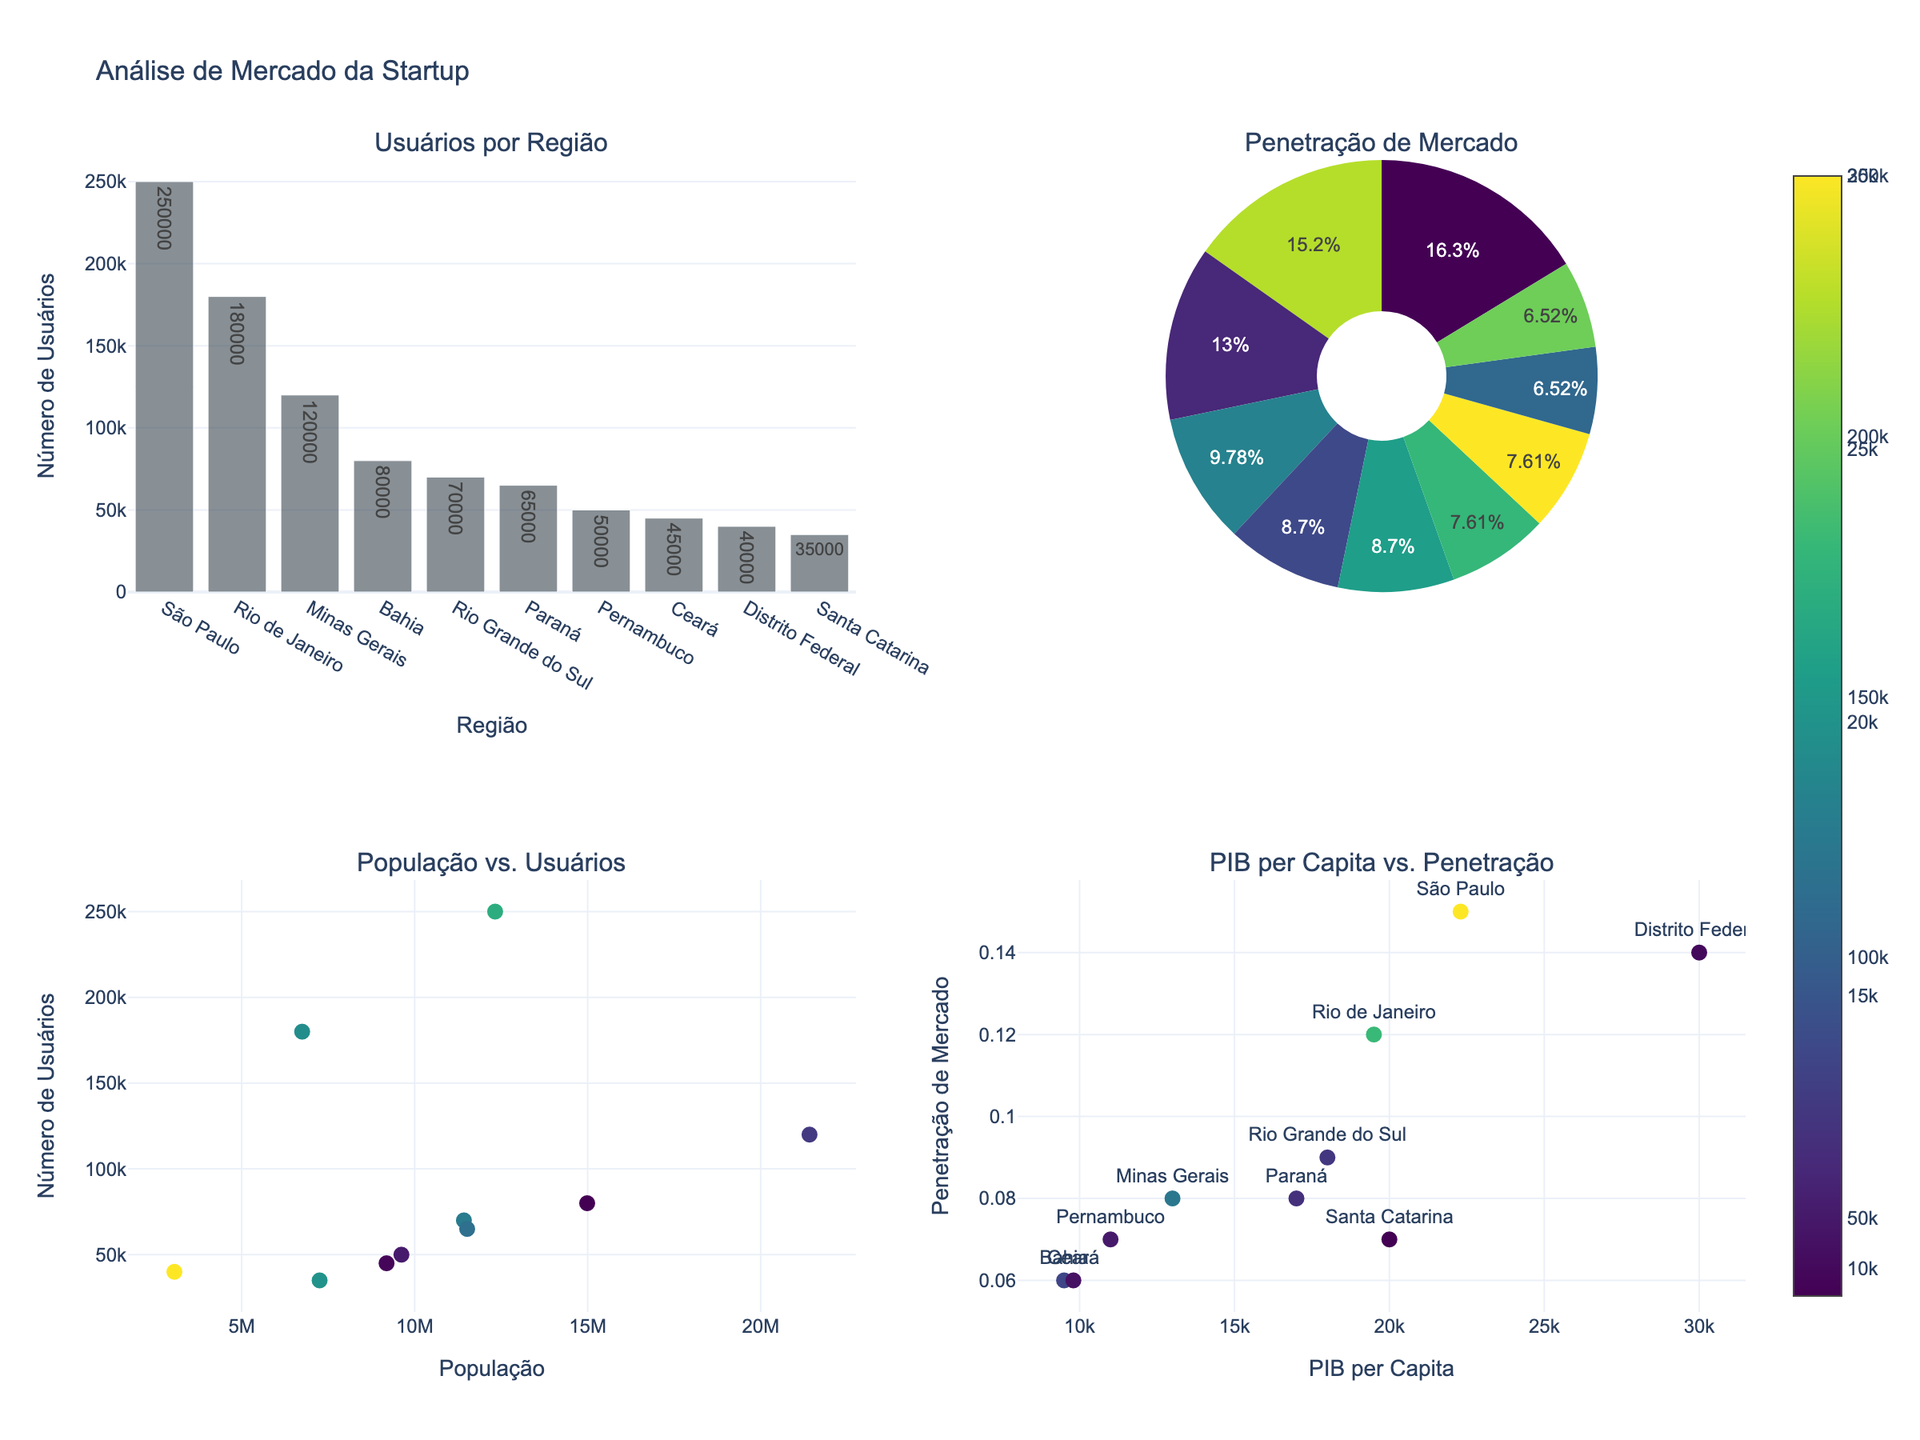What's the region with the highest number of users? The bar chart on the top-left subplot shows the number of users by region. The tallest bar represents São Paulo.
Answer: São Paulo Which region has the second-highest market penetration rate according to the pie chart? The pie chart on the top-right subplot shows market penetration rates. Distrito Federal has the highest market penetration (14%), and São Paulo has the second-highest (15%).
Answer: São Paulo What's the GDP per capita of Paraná? The scatter plot on the bottom-right subplot displays GDP per capita versus market penetration. Paraná is labeled, and you can see its position on the x-axis (around 17,000).
Answer: 17,000 Which region has the lowest number of users? The bar chart on the top-left subplot lists the number of users in each region. The smallest bar represents Santa Catarina.
Answer: Santa Catarina What's the relationship between population and users in different regions? The scatter plot on the bottom-left subplot illustrates population versus users, showing a trend that regions with higher populations tend to have more users.
Answer: Higher population regions tend to have more users Compare the users between Rio de Janeiro and Minas Gerais. The bar chart on the top-left subplot shows the number of users. Rio de Janeiro has 180,000 users, and Minas Gerais has 120,000 users.
Answer: Rio de Janeiro has more users Which region appears to be an outlier in terms of GDP per capita and market penetration, and why? The scatter plot on the bottom-right subplot shows GDP per capita versus market penetration. Distrito Federal is an outlier due to its high GDP per capita (30,000) and significant market penetration (0.14).
Answer: Distrito Federal (high GDP and market penetration) What can you infer about the relationship between GDP per capita and market penetration rate from the bottom-right scatter plot? The scatter plot shows that regions with higher GDP per capita generally have higher market penetration, though there are some exceptions.
Answer: Higher GDP tends to correlate with higher market penetration Which regions have a market penetration rate of 0.08? The pie chart displays market penetration rates. Minas Gerais and Paraná both have a market penetration rate of 0.08.
Answer: Minas Gerais and Paraná 